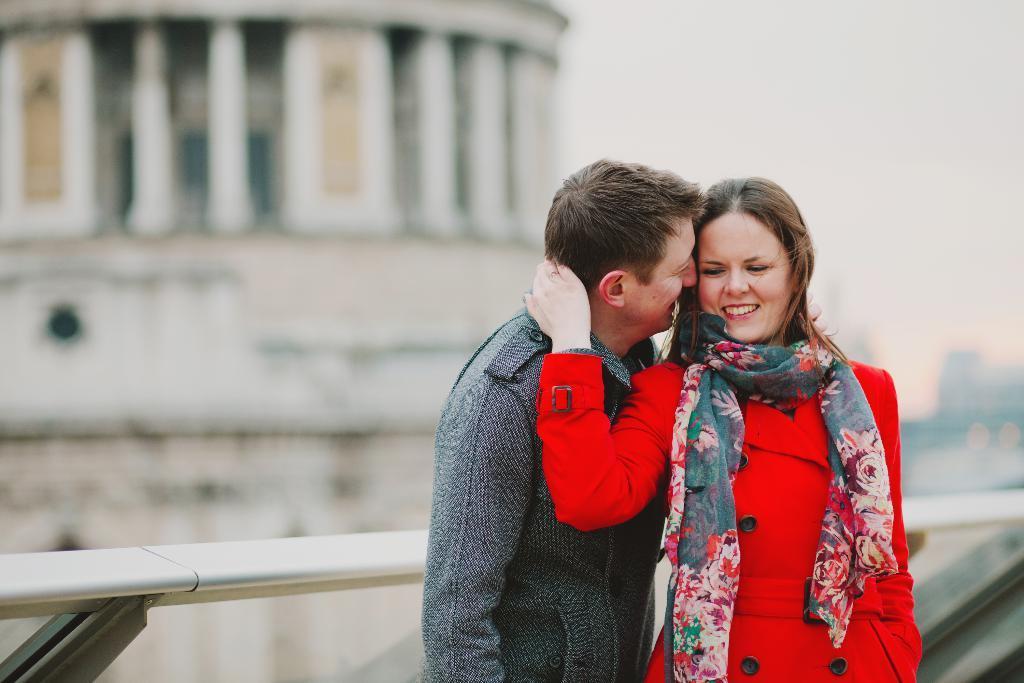In one or two sentences, can you explain what this image depicts? In the foreground of the picture there are a couple standing near by railing. The background is blurred. In the background there are buildings. 